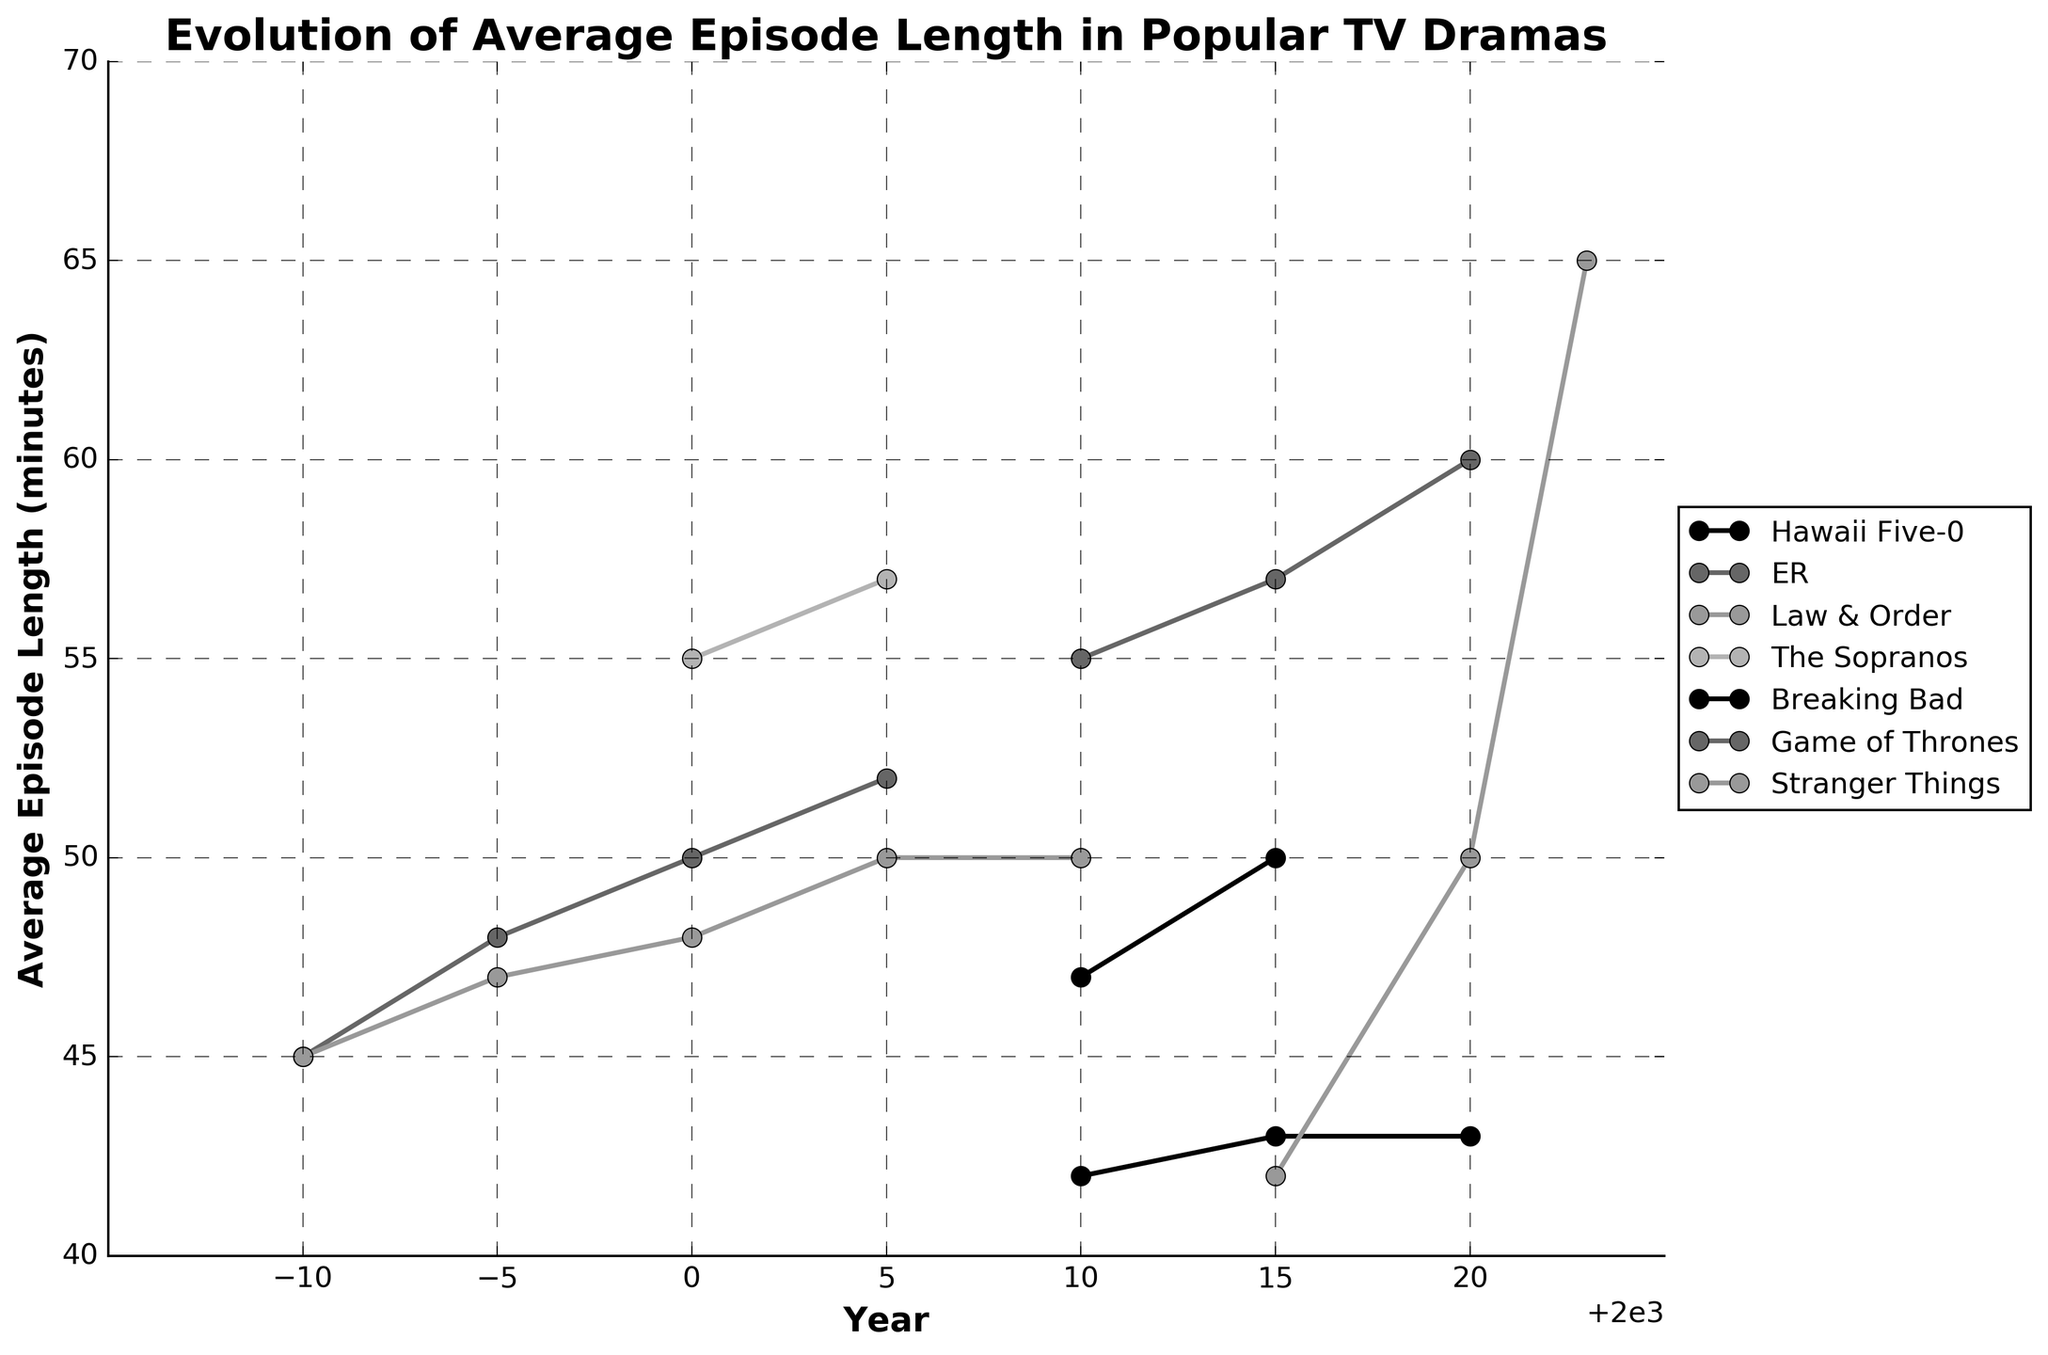What's the trend of average episode length for 'Law & Order' between 1990 and 2005? To find the trend for 'Law & Order' between 1990 and 2005, observe the values on the line plot for those years. The values are 45 minutes in 1990, increasing to 47, 48, and finally 50 minutes by 2005. This indicates a rising trend in episode length over the years.
Answer: Increasing How does the episode length of 'Stranger Things' in 2023 compare to that in 2015? From the plot, 'Stranger Things' had an average episode length of 42 minutes in 2015 and increased to 65 minutes in 2023. Comparing these values, we see an increase of 23 minutes.
Answer: Increased Which TV drama had the longest average episode length in 2020? For 2020, examine the plot and identify the highest point among the lines. 'Game of Thrones' shows an average episode length of 60 minutes, which is higher than others listed for that year.
Answer: Game of Thrones What's the difference in average episode length for 'ER' between 1990 and 2005? 'ER' had an average episode length of 45 minutes in 1990. By 2005, it increased to 52 minutes. Calculate the difference: 52 - 45 = 7.
Answer: 7 minutes What is the average episode length for 'The Sopranos' over all the years it is listed in the figure? 'The Sopranos' is listed for the years 2000 and 2005 with lengths of 55 and 57 minutes, respectively. The average is (55 + 57) / 2 = 56.
Answer: 56 minutes Comparing 'Breaking Bad's episode length in 2010 to 'Hawaii Five-0' in 2010, which show had a longer episode length? In 2010, 'Breaking Bad' episodes were 47 minutes long, whereas 'Hawaii Five-0' episodes were 42 minutes long. Comparing these, 'Breaking Bad' had longer episodes.
Answer: Breaking Bad What is the overall trend for 'Breaking Bad' in the years it is listed in the figure? 'Breaking Bad' only has values listed for 2010 and 2015 with 47 and 50 minutes respectively. The trend is increasing.
Answer: Increasing How many minutes longer were the episodes of 'Game of Thrones' in 2020 compared to 'ER' in 2000? 'Game of Thrones' in 2020 had an episode length of 60 minutes, and 'ER' in 2000 was 50 minutes. The difference is 60 - 50 = 10.
Answer: 10 minutes Are any TV dramas missing data after their initial appearance? If so, name one. Observing the plot reveals gaps in 'ER', which shows data until 2005, and then no data. Similarly, 'Law & Order' also lacks data after 2005. 'ER' is one example.
Answer: ER Among the listed shows, which one has the most recent data and what's its episode length? The most recent data is for 'Stranger Things' in 2023, with an average episode length of 65 minutes.
Answer: Stranger Things, 65 